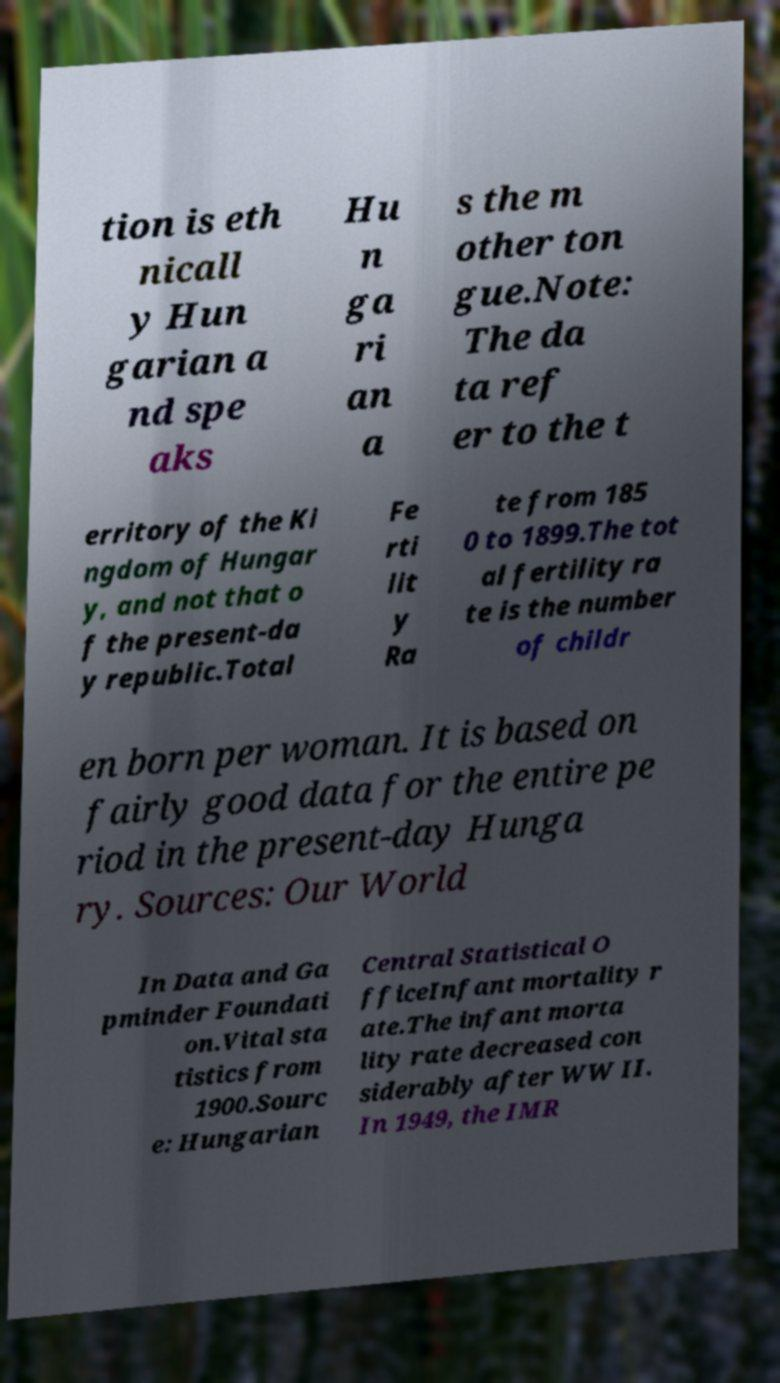I need the written content from this picture converted into text. Can you do that? tion is eth nicall y Hun garian a nd spe aks Hu n ga ri an a s the m other ton gue.Note: The da ta ref er to the t erritory of the Ki ngdom of Hungar y, and not that o f the present-da y republic.Total Fe rti lit y Ra te from 185 0 to 1899.The tot al fertility ra te is the number of childr en born per woman. It is based on fairly good data for the entire pe riod in the present-day Hunga ry. Sources: Our World In Data and Ga pminder Foundati on.Vital sta tistics from 1900.Sourc e: Hungarian Central Statistical O fficeInfant mortality r ate.The infant morta lity rate decreased con siderably after WW II. In 1949, the IMR 